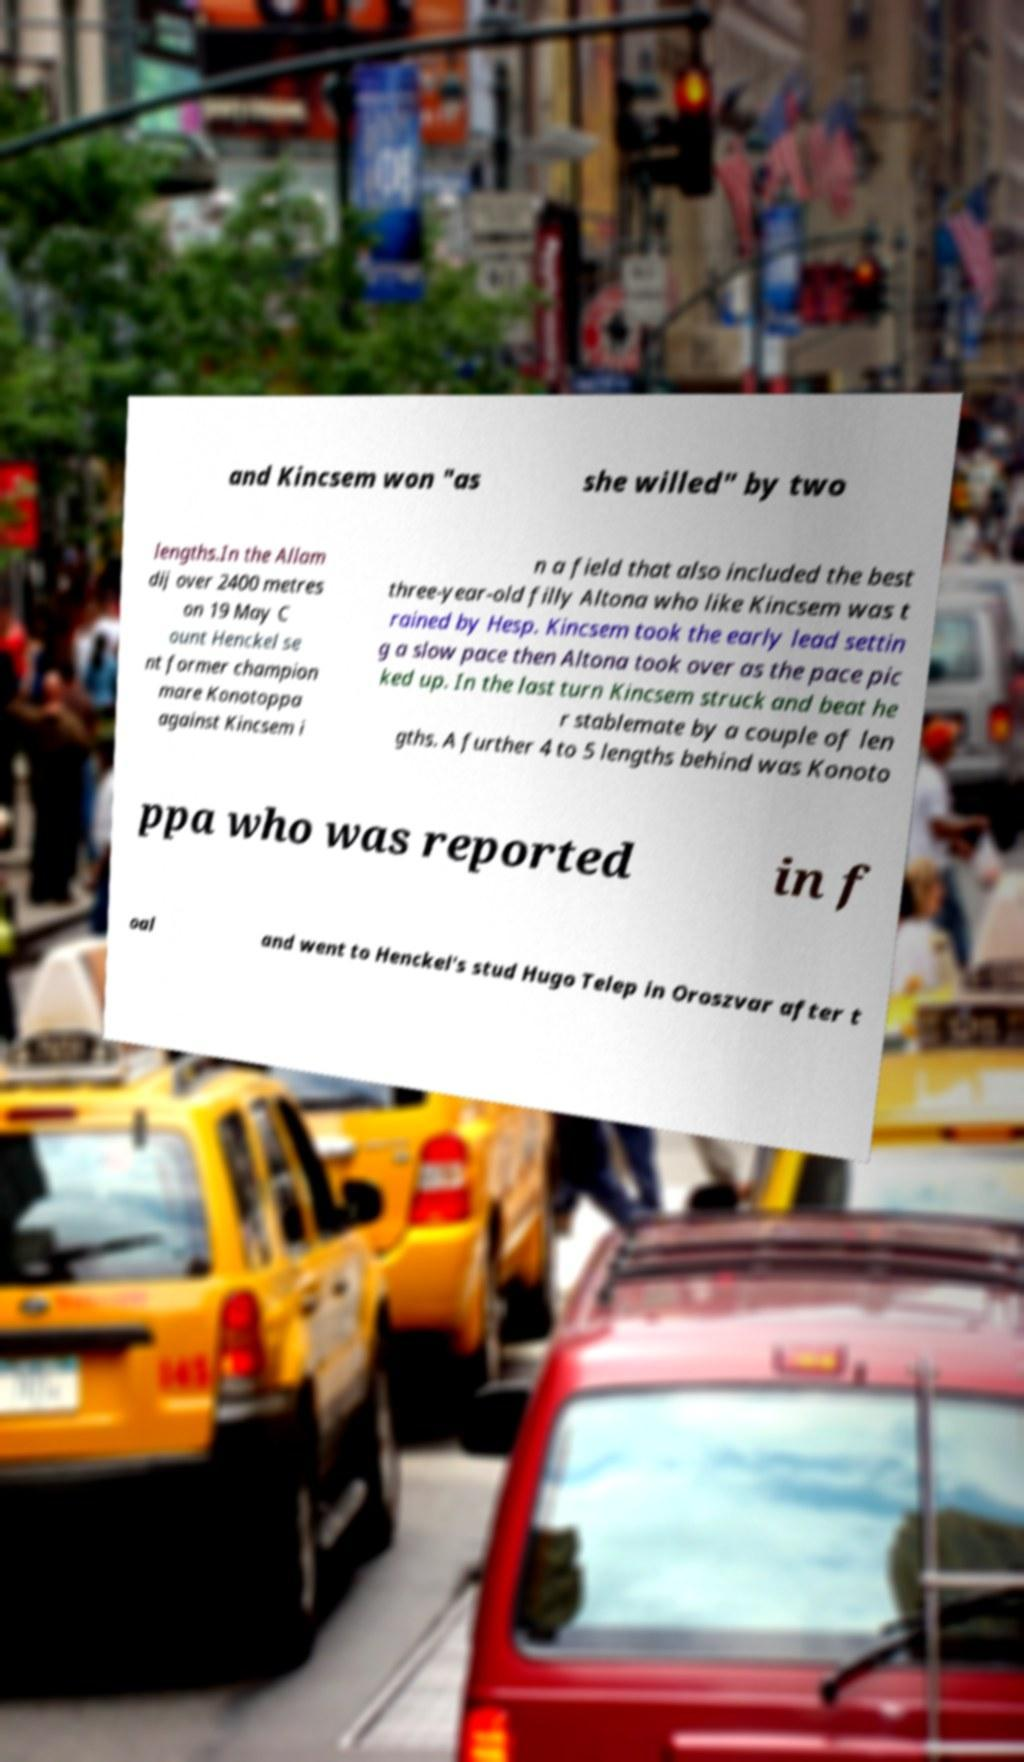Can you accurately transcribe the text from the provided image for me? and Kincsem won "as she willed" by two lengths.In the Allam dij over 2400 metres on 19 May C ount Henckel se nt former champion mare Konotoppa against Kincsem i n a field that also included the best three-year-old filly Altona who like Kincsem was t rained by Hesp. Kincsem took the early lead settin g a slow pace then Altona took over as the pace pic ked up. In the last turn Kincsem struck and beat he r stablemate by a couple of len gths. A further 4 to 5 lengths behind was Konoto ppa who was reported in f oal and went to Henckel's stud Hugo Telep in Oroszvar after t 